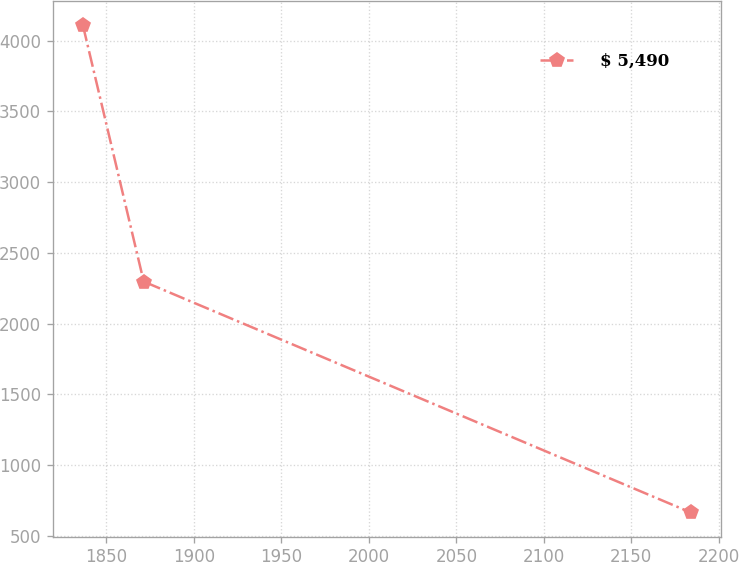Convert chart. <chart><loc_0><loc_0><loc_500><loc_500><line_chart><ecel><fcel>$ 5,490<nl><fcel>1836.54<fcel>4108.36<nl><fcel>1871.28<fcel>2297.76<nl><fcel>2183.91<fcel>665.92<nl></chart> 